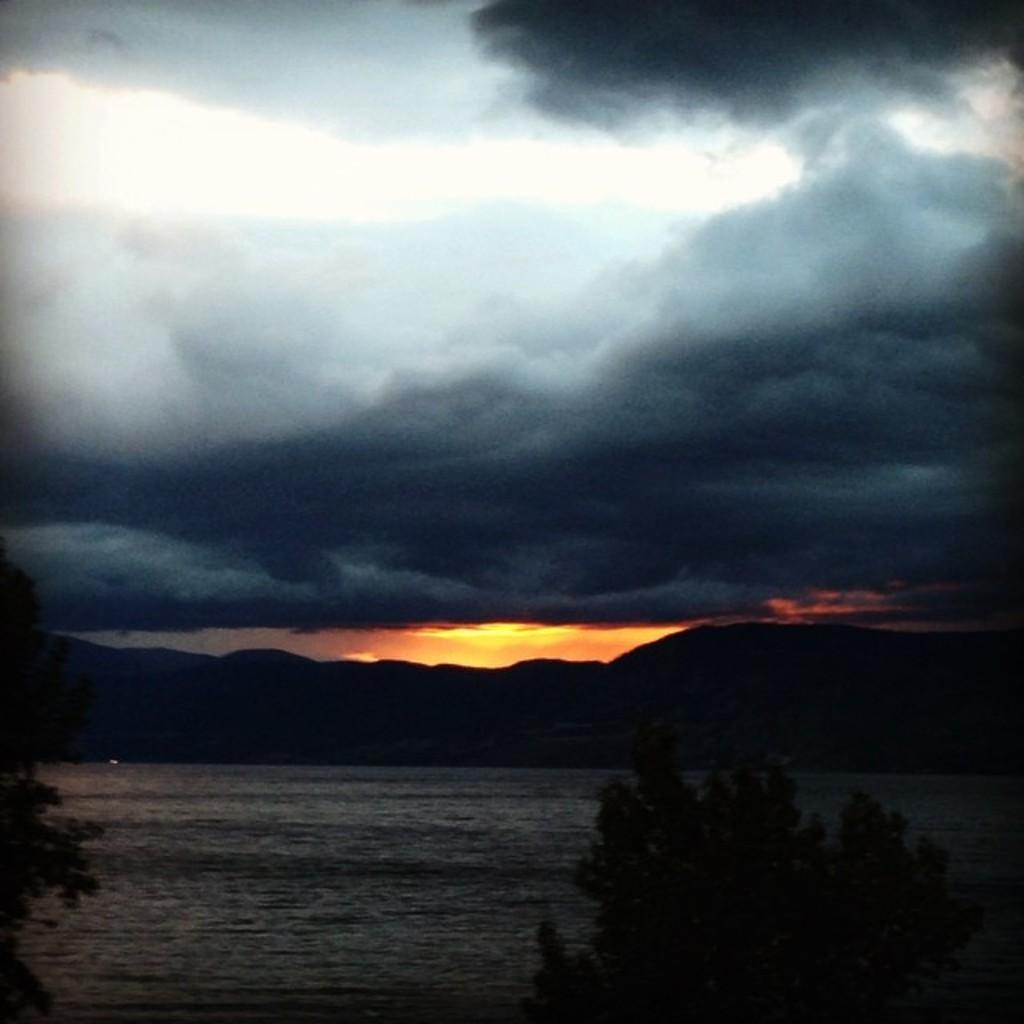What type of vegetation can be seen in the image? There are trees in the image. What natural element is visible in the image? There is water visible in the image. What can be seen in the distance in the image? There are hills in the background of the image. What is visible in the sky in the image? The sky is visible in the background of the image, and clouds are present. What type of toothpaste is being used to paint the art in the image? There is no art or toothpaste present in the image. What type of flowers can be seen growing near the trees in the image? There are no flowers mentioned or visible in the image; only trees are present. 